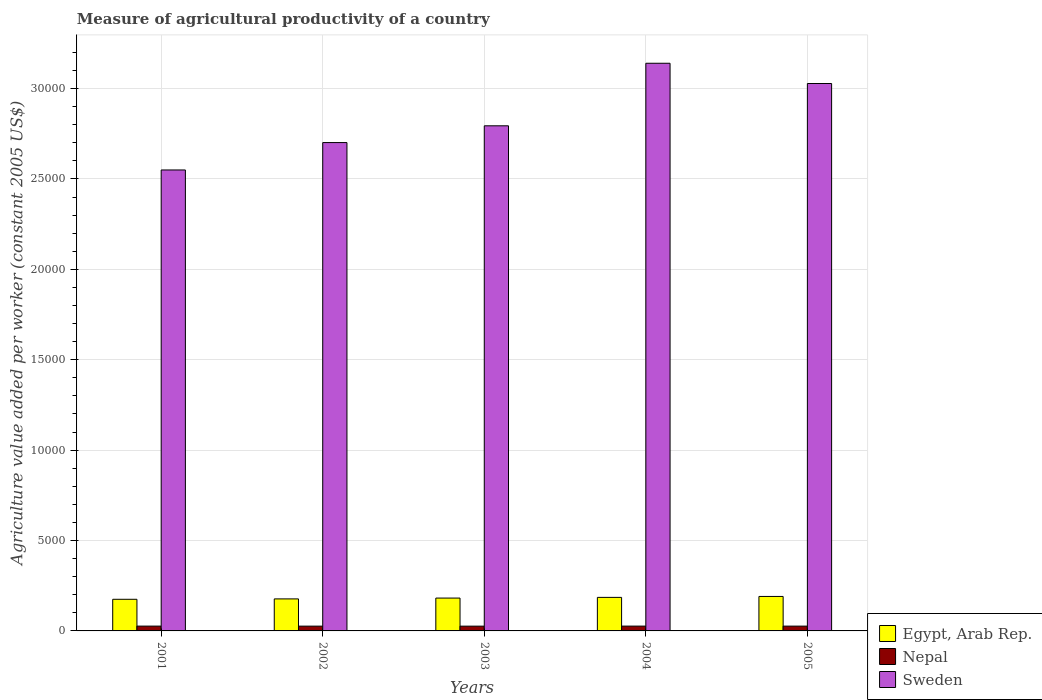What is the label of the 4th group of bars from the left?
Keep it short and to the point. 2004. What is the measure of agricultural productivity in Sweden in 2001?
Keep it short and to the point. 2.55e+04. Across all years, what is the maximum measure of agricultural productivity in Egypt, Arab Rep.?
Make the answer very short. 1906.89. Across all years, what is the minimum measure of agricultural productivity in Nepal?
Your response must be concise. 263.89. In which year was the measure of agricultural productivity in Egypt, Arab Rep. maximum?
Your response must be concise. 2005. In which year was the measure of agricultural productivity in Sweden minimum?
Offer a terse response. 2001. What is the total measure of agricultural productivity in Nepal in the graph?
Keep it short and to the point. 1327.07. What is the difference between the measure of agricultural productivity in Egypt, Arab Rep. in 2001 and that in 2005?
Your answer should be compact. -157.64. What is the difference between the measure of agricultural productivity in Nepal in 2003 and the measure of agricultural productivity in Sweden in 2001?
Make the answer very short. -2.52e+04. What is the average measure of agricultural productivity in Sweden per year?
Keep it short and to the point. 2.84e+04. In the year 2004, what is the difference between the measure of agricultural productivity in Sweden and measure of agricultural productivity in Nepal?
Ensure brevity in your answer.  3.11e+04. In how many years, is the measure of agricultural productivity in Egypt, Arab Rep. greater than 13000 US$?
Keep it short and to the point. 0. What is the ratio of the measure of agricultural productivity in Egypt, Arab Rep. in 2001 to that in 2002?
Your answer should be very brief. 0.99. Is the difference between the measure of agricultural productivity in Sweden in 2002 and 2003 greater than the difference between the measure of agricultural productivity in Nepal in 2002 and 2003?
Offer a very short reply. No. What is the difference between the highest and the second highest measure of agricultural productivity in Sweden?
Give a very brief answer. 1120.04. What is the difference between the highest and the lowest measure of agricultural productivity in Nepal?
Keep it short and to the point. 2.62. Is the sum of the measure of agricultural productivity in Sweden in 2003 and 2005 greater than the maximum measure of agricultural productivity in Egypt, Arab Rep. across all years?
Your answer should be very brief. Yes. What does the 2nd bar from the left in 2003 represents?
Ensure brevity in your answer.  Nepal. What does the 3rd bar from the right in 2005 represents?
Provide a succinct answer. Egypt, Arab Rep. Are all the bars in the graph horizontal?
Offer a terse response. No. How many years are there in the graph?
Offer a terse response. 5. What is the difference between two consecutive major ticks on the Y-axis?
Provide a short and direct response. 5000. Are the values on the major ticks of Y-axis written in scientific E-notation?
Your response must be concise. No. Does the graph contain grids?
Provide a short and direct response. Yes. Where does the legend appear in the graph?
Provide a short and direct response. Bottom right. How are the legend labels stacked?
Ensure brevity in your answer.  Vertical. What is the title of the graph?
Your answer should be compact. Measure of agricultural productivity of a country. Does "Turks and Caicos Islands" appear as one of the legend labels in the graph?
Ensure brevity in your answer.  No. What is the label or title of the X-axis?
Ensure brevity in your answer.  Years. What is the label or title of the Y-axis?
Provide a succinct answer. Agriculture value added per worker (constant 2005 US$). What is the Agriculture value added per worker (constant 2005 US$) in Egypt, Arab Rep. in 2001?
Ensure brevity in your answer.  1749.25. What is the Agriculture value added per worker (constant 2005 US$) of Nepal in 2001?
Give a very brief answer. 266.18. What is the Agriculture value added per worker (constant 2005 US$) in Sweden in 2001?
Your response must be concise. 2.55e+04. What is the Agriculture value added per worker (constant 2005 US$) in Egypt, Arab Rep. in 2002?
Provide a succinct answer. 1770.92. What is the Agriculture value added per worker (constant 2005 US$) of Nepal in 2002?
Provide a short and direct response. 264.84. What is the Agriculture value added per worker (constant 2005 US$) in Sweden in 2002?
Make the answer very short. 2.70e+04. What is the Agriculture value added per worker (constant 2005 US$) of Egypt, Arab Rep. in 2003?
Keep it short and to the point. 1817.06. What is the Agriculture value added per worker (constant 2005 US$) in Nepal in 2003?
Offer a terse response. 263.89. What is the Agriculture value added per worker (constant 2005 US$) of Sweden in 2003?
Give a very brief answer. 2.79e+04. What is the Agriculture value added per worker (constant 2005 US$) in Egypt, Arab Rep. in 2004?
Your response must be concise. 1854.93. What is the Agriculture value added per worker (constant 2005 US$) in Nepal in 2004?
Keep it short and to the point. 266.51. What is the Agriculture value added per worker (constant 2005 US$) in Sweden in 2004?
Offer a very short reply. 3.14e+04. What is the Agriculture value added per worker (constant 2005 US$) of Egypt, Arab Rep. in 2005?
Keep it short and to the point. 1906.89. What is the Agriculture value added per worker (constant 2005 US$) of Nepal in 2005?
Your answer should be compact. 265.65. What is the Agriculture value added per worker (constant 2005 US$) of Sweden in 2005?
Offer a terse response. 3.03e+04. Across all years, what is the maximum Agriculture value added per worker (constant 2005 US$) of Egypt, Arab Rep.?
Ensure brevity in your answer.  1906.89. Across all years, what is the maximum Agriculture value added per worker (constant 2005 US$) in Nepal?
Your response must be concise. 266.51. Across all years, what is the maximum Agriculture value added per worker (constant 2005 US$) in Sweden?
Provide a succinct answer. 3.14e+04. Across all years, what is the minimum Agriculture value added per worker (constant 2005 US$) of Egypt, Arab Rep.?
Give a very brief answer. 1749.25. Across all years, what is the minimum Agriculture value added per worker (constant 2005 US$) in Nepal?
Make the answer very short. 263.89. Across all years, what is the minimum Agriculture value added per worker (constant 2005 US$) of Sweden?
Offer a very short reply. 2.55e+04. What is the total Agriculture value added per worker (constant 2005 US$) in Egypt, Arab Rep. in the graph?
Keep it short and to the point. 9099.05. What is the total Agriculture value added per worker (constant 2005 US$) of Nepal in the graph?
Make the answer very short. 1327.07. What is the total Agriculture value added per worker (constant 2005 US$) in Sweden in the graph?
Your answer should be compact. 1.42e+05. What is the difference between the Agriculture value added per worker (constant 2005 US$) in Egypt, Arab Rep. in 2001 and that in 2002?
Make the answer very short. -21.67. What is the difference between the Agriculture value added per worker (constant 2005 US$) in Nepal in 2001 and that in 2002?
Your response must be concise. 1.33. What is the difference between the Agriculture value added per worker (constant 2005 US$) in Sweden in 2001 and that in 2002?
Give a very brief answer. -1514.82. What is the difference between the Agriculture value added per worker (constant 2005 US$) of Egypt, Arab Rep. in 2001 and that in 2003?
Give a very brief answer. -67.81. What is the difference between the Agriculture value added per worker (constant 2005 US$) of Nepal in 2001 and that in 2003?
Make the answer very short. 2.29. What is the difference between the Agriculture value added per worker (constant 2005 US$) of Sweden in 2001 and that in 2003?
Keep it short and to the point. -2442.16. What is the difference between the Agriculture value added per worker (constant 2005 US$) in Egypt, Arab Rep. in 2001 and that in 2004?
Provide a short and direct response. -105.68. What is the difference between the Agriculture value added per worker (constant 2005 US$) in Nepal in 2001 and that in 2004?
Your response must be concise. -0.33. What is the difference between the Agriculture value added per worker (constant 2005 US$) in Sweden in 2001 and that in 2004?
Provide a succinct answer. -5902.1. What is the difference between the Agriculture value added per worker (constant 2005 US$) of Egypt, Arab Rep. in 2001 and that in 2005?
Your answer should be very brief. -157.64. What is the difference between the Agriculture value added per worker (constant 2005 US$) in Nepal in 2001 and that in 2005?
Offer a very short reply. 0.52. What is the difference between the Agriculture value added per worker (constant 2005 US$) of Sweden in 2001 and that in 2005?
Your answer should be compact. -4782.06. What is the difference between the Agriculture value added per worker (constant 2005 US$) in Egypt, Arab Rep. in 2002 and that in 2003?
Offer a very short reply. -46.13. What is the difference between the Agriculture value added per worker (constant 2005 US$) of Nepal in 2002 and that in 2003?
Keep it short and to the point. 0.96. What is the difference between the Agriculture value added per worker (constant 2005 US$) of Sweden in 2002 and that in 2003?
Make the answer very short. -927.34. What is the difference between the Agriculture value added per worker (constant 2005 US$) in Egypt, Arab Rep. in 2002 and that in 2004?
Give a very brief answer. -84.01. What is the difference between the Agriculture value added per worker (constant 2005 US$) of Nepal in 2002 and that in 2004?
Offer a terse response. -1.67. What is the difference between the Agriculture value added per worker (constant 2005 US$) of Sweden in 2002 and that in 2004?
Provide a short and direct response. -4387.28. What is the difference between the Agriculture value added per worker (constant 2005 US$) of Egypt, Arab Rep. in 2002 and that in 2005?
Offer a terse response. -135.96. What is the difference between the Agriculture value added per worker (constant 2005 US$) in Nepal in 2002 and that in 2005?
Your answer should be compact. -0.81. What is the difference between the Agriculture value added per worker (constant 2005 US$) of Sweden in 2002 and that in 2005?
Your answer should be very brief. -3267.24. What is the difference between the Agriculture value added per worker (constant 2005 US$) of Egypt, Arab Rep. in 2003 and that in 2004?
Your answer should be compact. -37.88. What is the difference between the Agriculture value added per worker (constant 2005 US$) of Nepal in 2003 and that in 2004?
Keep it short and to the point. -2.62. What is the difference between the Agriculture value added per worker (constant 2005 US$) in Sweden in 2003 and that in 2004?
Make the answer very short. -3459.94. What is the difference between the Agriculture value added per worker (constant 2005 US$) in Egypt, Arab Rep. in 2003 and that in 2005?
Offer a terse response. -89.83. What is the difference between the Agriculture value added per worker (constant 2005 US$) in Nepal in 2003 and that in 2005?
Ensure brevity in your answer.  -1.77. What is the difference between the Agriculture value added per worker (constant 2005 US$) of Sweden in 2003 and that in 2005?
Give a very brief answer. -2339.9. What is the difference between the Agriculture value added per worker (constant 2005 US$) in Egypt, Arab Rep. in 2004 and that in 2005?
Provide a short and direct response. -51.95. What is the difference between the Agriculture value added per worker (constant 2005 US$) in Nepal in 2004 and that in 2005?
Your answer should be compact. 0.86. What is the difference between the Agriculture value added per worker (constant 2005 US$) in Sweden in 2004 and that in 2005?
Provide a succinct answer. 1120.04. What is the difference between the Agriculture value added per worker (constant 2005 US$) of Egypt, Arab Rep. in 2001 and the Agriculture value added per worker (constant 2005 US$) of Nepal in 2002?
Your answer should be compact. 1484.41. What is the difference between the Agriculture value added per worker (constant 2005 US$) in Egypt, Arab Rep. in 2001 and the Agriculture value added per worker (constant 2005 US$) in Sweden in 2002?
Offer a terse response. -2.53e+04. What is the difference between the Agriculture value added per worker (constant 2005 US$) in Nepal in 2001 and the Agriculture value added per worker (constant 2005 US$) in Sweden in 2002?
Provide a succinct answer. -2.67e+04. What is the difference between the Agriculture value added per worker (constant 2005 US$) in Egypt, Arab Rep. in 2001 and the Agriculture value added per worker (constant 2005 US$) in Nepal in 2003?
Make the answer very short. 1485.36. What is the difference between the Agriculture value added per worker (constant 2005 US$) of Egypt, Arab Rep. in 2001 and the Agriculture value added per worker (constant 2005 US$) of Sweden in 2003?
Provide a short and direct response. -2.62e+04. What is the difference between the Agriculture value added per worker (constant 2005 US$) in Nepal in 2001 and the Agriculture value added per worker (constant 2005 US$) in Sweden in 2003?
Your response must be concise. -2.77e+04. What is the difference between the Agriculture value added per worker (constant 2005 US$) in Egypt, Arab Rep. in 2001 and the Agriculture value added per worker (constant 2005 US$) in Nepal in 2004?
Provide a short and direct response. 1482.74. What is the difference between the Agriculture value added per worker (constant 2005 US$) in Egypt, Arab Rep. in 2001 and the Agriculture value added per worker (constant 2005 US$) in Sweden in 2004?
Give a very brief answer. -2.96e+04. What is the difference between the Agriculture value added per worker (constant 2005 US$) of Nepal in 2001 and the Agriculture value added per worker (constant 2005 US$) of Sweden in 2004?
Your answer should be very brief. -3.11e+04. What is the difference between the Agriculture value added per worker (constant 2005 US$) in Egypt, Arab Rep. in 2001 and the Agriculture value added per worker (constant 2005 US$) in Nepal in 2005?
Provide a short and direct response. 1483.6. What is the difference between the Agriculture value added per worker (constant 2005 US$) of Egypt, Arab Rep. in 2001 and the Agriculture value added per worker (constant 2005 US$) of Sweden in 2005?
Your response must be concise. -2.85e+04. What is the difference between the Agriculture value added per worker (constant 2005 US$) in Nepal in 2001 and the Agriculture value added per worker (constant 2005 US$) in Sweden in 2005?
Offer a terse response. -3.00e+04. What is the difference between the Agriculture value added per worker (constant 2005 US$) of Egypt, Arab Rep. in 2002 and the Agriculture value added per worker (constant 2005 US$) of Nepal in 2003?
Offer a very short reply. 1507.04. What is the difference between the Agriculture value added per worker (constant 2005 US$) of Egypt, Arab Rep. in 2002 and the Agriculture value added per worker (constant 2005 US$) of Sweden in 2003?
Ensure brevity in your answer.  -2.62e+04. What is the difference between the Agriculture value added per worker (constant 2005 US$) in Nepal in 2002 and the Agriculture value added per worker (constant 2005 US$) in Sweden in 2003?
Offer a terse response. -2.77e+04. What is the difference between the Agriculture value added per worker (constant 2005 US$) in Egypt, Arab Rep. in 2002 and the Agriculture value added per worker (constant 2005 US$) in Nepal in 2004?
Offer a very short reply. 1504.41. What is the difference between the Agriculture value added per worker (constant 2005 US$) in Egypt, Arab Rep. in 2002 and the Agriculture value added per worker (constant 2005 US$) in Sweden in 2004?
Ensure brevity in your answer.  -2.96e+04. What is the difference between the Agriculture value added per worker (constant 2005 US$) in Nepal in 2002 and the Agriculture value added per worker (constant 2005 US$) in Sweden in 2004?
Offer a terse response. -3.11e+04. What is the difference between the Agriculture value added per worker (constant 2005 US$) in Egypt, Arab Rep. in 2002 and the Agriculture value added per worker (constant 2005 US$) in Nepal in 2005?
Ensure brevity in your answer.  1505.27. What is the difference between the Agriculture value added per worker (constant 2005 US$) in Egypt, Arab Rep. in 2002 and the Agriculture value added per worker (constant 2005 US$) in Sweden in 2005?
Your answer should be compact. -2.85e+04. What is the difference between the Agriculture value added per worker (constant 2005 US$) of Nepal in 2002 and the Agriculture value added per worker (constant 2005 US$) of Sweden in 2005?
Your answer should be compact. -3.00e+04. What is the difference between the Agriculture value added per worker (constant 2005 US$) in Egypt, Arab Rep. in 2003 and the Agriculture value added per worker (constant 2005 US$) in Nepal in 2004?
Provide a short and direct response. 1550.55. What is the difference between the Agriculture value added per worker (constant 2005 US$) of Egypt, Arab Rep. in 2003 and the Agriculture value added per worker (constant 2005 US$) of Sweden in 2004?
Offer a terse response. -2.96e+04. What is the difference between the Agriculture value added per worker (constant 2005 US$) in Nepal in 2003 and the Agriculture value added per worker (constant 2005 US$) in Sweden in 2004?
Make the answer very short. -3.11e+04. What is the difference between the Agriculture value added per worker (constant 2005 US$) in Egypt, Arab Rep. in 2003 and the Agriculture value added per worker (constant 2005 US$) in Nepal in 2005?
Ensure brevity in your answer.  1551.4. What is the difference between the Agriculture value added per worker (constant 2005 US$) in Egypt, Arab Rep. in 2003 and the Agriculture value added per worker (constant 2005 US$) in Sweden in 2005?
Your answer should be very brief. -2.85e+04. What is the difference between the Agriculture value added per worker (constant 2005 US$) in Nepal in 2003 and the Agriculture value added per worker (constant 2005 US$) in Sweden in 2005?
Ensure brevity in your answer.  -3.00e+04. What is the difference between the Agriculture value added per worker (constant 2005 US$) of Egypt, Arab Rep. in 2004 and the Agriculture value added per worker (constant 2005 US$) of Nepal in 2005?
Your response must be concise. 1589.28. What is the difference between the Agriculture value added per worker (constant 2005 US$) in Egypt, Arab Rep. in 2004 and the Agriculture value added per worker (constant 2005 US$) in Sweden in 2005?
Keep it short and to the point. -2.84e+04. What is the difference between the Agriculture value added per worker (constant 2005 US$) of Nepal in 2004 and the Agriculture value added per worker (constant 2005 US$) of Sweden in 2005?
Offer a terse response. -3.00e+04. What is the average Agriculture value added per worker (constant 2005 US$) in Egypt, Arab Rep. per year?
Ensure brevity in your answer.  1819.81. What is the average Agriculture value added per worker (constant 2005 US$) in Nepal per year?
Make the answer very short. 265.41. What is the average Agriculture value added per worker (constant 2005 US$) in Sweden per year?
Offer a terse response. 2.84e+04. In the year 2001, what is the difference between the Agriculture value added per worker (constant 2005 US$) in Egypt, Arab Rep. and Agriculture value added per worker (constant 2005 US$) in Nepal?
Give a very brief answer. 1483.07. In the year 2001, what is the difference between the Agriculture value added per worker (constant 2005 US$) in Egypt, Arab Rep. and Agriculture value added per worker (constant 2005 US$) in Sweden?
Make the answer very short. -2.37e+04. In the year 2001, what is the difference between the Agriculture value added per worker (constant 2005 US$) of Nepal and Agriculture value added per worker (constant 2005 US$) of Sweden?
Provide a short and direct response. -2.52e+04. In the year 2002, what is the difference between the Agriculture value added per worker (constant 2005 US$) in Egypt, Arab Rep. and Agriculture value added per worker (constant 2005 US$) in Nepal?
Provide a succinct answer. 1506.08. In the year 2002, what is the difference between the Agriculture value added per worker (constant 2005 US$) of Egypt, Arab Rep. and Agriculture value added per worker (constant 2005 US$) of Sweden?
Ensure brevity in your answer.  -2.52e+04. In the year 2002, what is the difference between the Agriculture value added per worker (constant 2005 US$) of Nepal and Agriculture value added per worker (constant 2005 US$) of Sweden?
Your answer should be very brief. -2.67e+04. In the year 2003, what is the difference between the Agriculture value added per worker (constant 2005 US$) of Egypt, Arab Rep. and Agriculture value added per worker (constant 2005 US$) of Nepal?
Ensure brevity in your answer.  1553.17. In the year 2003, what is the difference between the Agriculture value added per worker (constant 2005 US$) of Egypt, Arab Rep. and Agriculture value added per worker (constant 2005 US$) of Sweden?
Make the answer very short. -2.61e+04. In the year 2003, what is the difference between the Agriculture value added per worker (constant 2005 US$) of Nepal and Agriculture value added per worker (constant 2005 US$) of Sweden?
Your answer should be compact. -2.77e+04. In the year 2004, what is the difference between the Agriculture value added per worker (constant 2005 US$) of Egypt, Arab Rep. and Agriculture value added per worker (constant 2005 US$) of Nepal?
Your answer should be very brief. 1588.42. In the year 2004, what is the difference between the Agriculture value added per worker (constant 2005 US$) of Egypt, Arab Rep. and Agriculture value added per worker (constant 2005 US$) of Sweden?
Provide a short and direct response. -2.95e+04. In the year 2004, what is the difference between the Agriculture value added per worker (constant 2005 US$) of Nepal and Agriculture value added per worker (constant 2005 US$) of Sweden?
Your answer should be very brief. -3.11e+04. In the year 2005, what is the difference between the Agriculture value added per worker (constant 2005 US$) in Egypt, Arab Rep. and Agriculture value added per worker (constant 2005 US$) in Nepal?
Provide a short and direct response. 1641.23. In the year 2005, what is the difference between the Agriculture value added per worker (constant 2005 US$) in Egypt, Arab Rep. and Agriculture value added per worker (constant 2005 US$) in Sweden?
Give a very brief answer. -2.84e+04. In the year 2005, what is the difference between the Agriculture value added per worker (constant 2005 US$) of Nepal and Agriculture value added per worker (constant 2005 US$) of Sweden?
Provide a succinct answer. -3.00e+04. What is the ratio of the Agriculture value added per worker (constant 2005 US$) of Egypt, Arab Rep. in 2001 to that in 2002?
Ensure brevity in your answer.  0.99. What is the ratio of the Agriculture value added per worker (constant 2005 US$) in Sweden in 2001 to that in 2002?
Offer a terse response. 0.94. What is the ratio of the Agriculture value added per worker (constant 2005 US$) of Egypt, Arab Rep. in 2001 to that in 2003?
Keep it short and to the point. 0.96. What is the ratio of the Agriculture value added per worker (constant 2005 US$) in Nepal in 2001 to that in 2003?
Offer a terse response. 1.01. What is the ratio of the Agriculture value added per worker (constant 2005 US$) in Sweden in 2001 to that in 2003?
Keep it short and to the point. 0.91. What is the ratio of the Agriculture value added per worker (constant 2005 US$) of Egypt, Arab Rep. in 2001 to that in 2004?
Offer a very short reply. 0.94. What is the ratio of the Agriculture value added per worker (constant 2005 US$) in Sweden in 2001 to that in 2004?
Provide a succinct answer. 0.81. What is the ratio of the Agriculture value added per worker (constant 2005 US$) in Egypt, Arab Rep. in 2001 to that in 2005?
Provide a succinct answer. 0.92. What is the ratio of the Agriculture value added per worker (constant 2005 US$) of Nepal in 2001 to that in 2005?
Ensure brevity in your answer.  1. What is the ratio of the Agriculture value added per worker (constant 2005 US$) of Sweden in 2001 to that in 2005?
Your answer should be very brief. 0.84. What is the ratio of the Agriculture value added per worker (constant 2005 US$) of Egypt, Arab Rep. in 2002 to that in 2003?
Provide a succinct answer. 0.97. What is the ratio of the Agriculture value added per worker (constant 2005 US$) in Sweden in 2002 to that in 2003?
Your answer should be compact. 0.97. What is the ratio of the Agriculture value added per worker (constant 2005 US$) in Egypt, Arab Rep. in 2002 to that in 2004?
Offer a very short reply. 0.95. What is the ratio of the Agriculture value added per worker (constant 2005 US$) in Sweden in 2002 to that in 2004?
Give a very brief answer. 0.86. What is the ratio of the Agriculture value added per worker (constant 2005 US$) in Egypt, Arab Rep. in 2002 to that in 2005?
Offer a very short reply. 0.93. What is the ratio of the Agriculture value added per worker (constant 2005 US$) in Nepal in 2002 to that in 2005?
Offer a very short reply. 1. What is the ratio of the Agriculture value added per worker (constant 2005 US$) of Sweden in 2002 to that in 2005?
Make the answer very short. 0.89. What is the ratio of the Agriculture value added per worker (constant 2005 US$) of Egypt, Arab Rep. in 2003 to that in 2004?
Your answer should be compact. 0.98. What is the ratio of the Agriculture value added per worker (constant 2005 US$) in Nepal in 2003 to that in 2004?
Make the answer very short. 0.99. What is the ratio of the Agriculture value added per worker (constant 2005 US$) of Sweden in 2003 to that in 2004?
Keep it short and to the point. 0.89. What is the ratio of the Agriculture value added per worker (constant 2005 US$) in Egypt, Arab Rep. in 2003 to that in 2005?
Your answer should be very brief. 0.95. What is the ratio of the Agriculture value added per worker (constant 2005 US$) of Nepal in 2003 to that in 2005?
Keep it short and to the point. 0.99. What is the ratio of the Agriculture value added per worker (constant 2005 US$) in Sweden in 2003 to that in 2005?
Your answer should be very brief. 0.92. What is the ratio of the Agriculture value added per worker (constant 2005 US$) of Egypt, Arab Rep. in 2004 to that in 2005?
Ensure brevity in your answer.  0.97. What is the ratio of the Agriculture value added per worker (constant 2005 US$) in Nepal in 2004 to that in 2005?
Your answer should be compact. 1. What is the ratio of the Agriculture value added per worker (constant 2005 US$) in Sweden in 2004 to that in 2005?
Keep it short and to the point. 1.04. What is the difference between the highest and the second highest Agriculture value added per worker (constant 2005 US$) of Egypt, Arab Rep.?
Your answer should be very brief. 51.95. What is the difference between the highest and the second highest Agriculture value added per worker (constant 2005 US$) of Nepal?
Your answer should be compact. 0.33. What is the difference between the highest and the second highest Agriculture value added per worker (constant 2005 US$) in Sweden?
Offer a terse response. 1120.04. What is the difference between the highest and the lowest Agriculture value added per worker (constant 2005 US$) of Egypt, Arab Rep.?
Ensure brevity in your answer.  157.64. What is the difference between the highest and the lowest Agriculture value added per worker (constant 2005 US$) in Nepal?
Your answer should be very brief. 2.62. What is the difference between the highest and the lowest Agriculture value added per worker (constant 2005 US$) in Sweden?
Your response must be concise. 5902.1. 